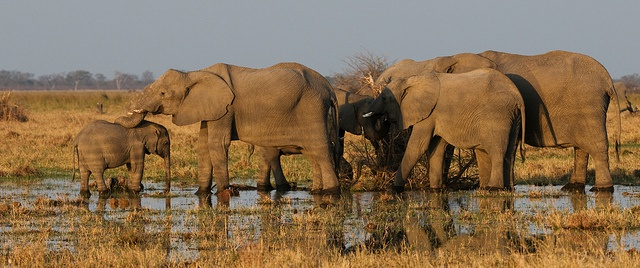Describe the objects in this image and their specific colors. I can see elephant in darkgray, olive, maroon, tan, and black tones, elephant in darkgray, olive, black, tan, and maroon tones, elephant in darkgray, olive, gray, black, and maroon tones, elephant in darkgray, olive, and maroon tones, and elephant in darkgray, black, maroon, and gray tones in this image. 